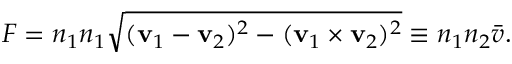<formula> <loc_0><loc_0><loc_500><loc_500>F = n _ { 1 } n _ { 1 } { \sqrt { ( v _ { 1 } - v _ { 2 } ) ^ { 2 } - ( v _ { 1 } \times v _ { 2 } ) ^ { 2 } } } \equiv n _ { 1 } n _ { 2 } { \bar { v } } .</formula> 